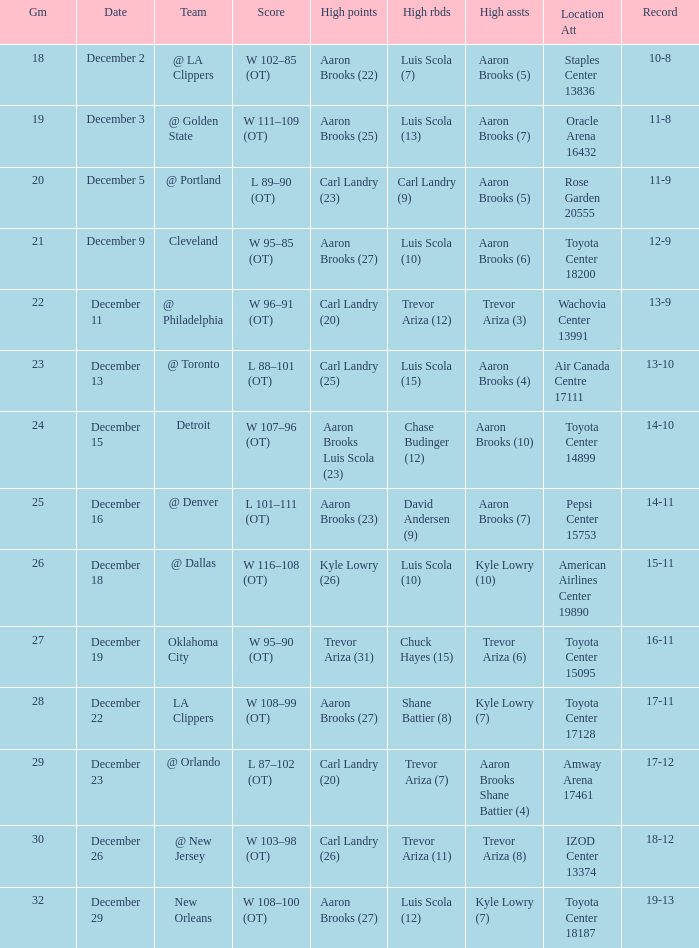Where was the game in which Carl Landry (25) did the most high points played? Air Canada Centre 17111. 